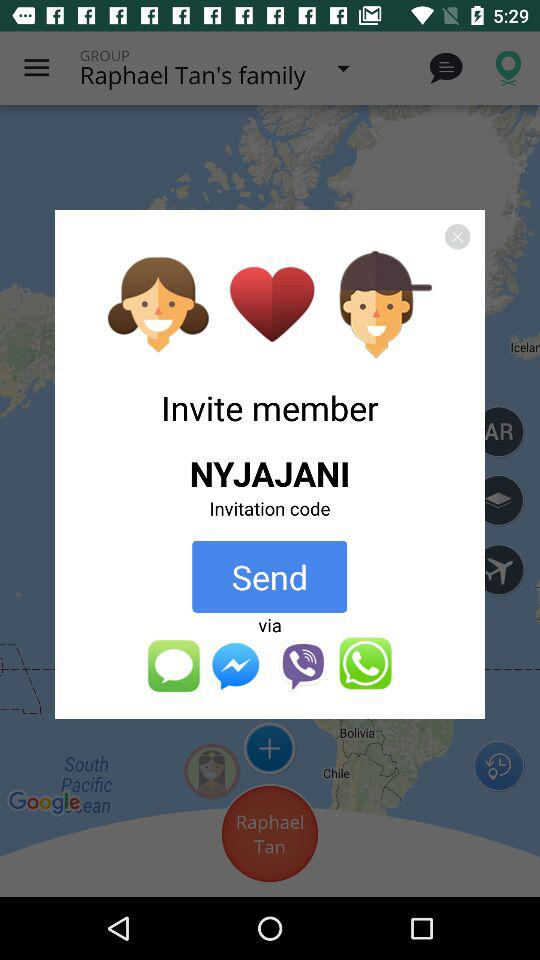Through which application can we share the invitation code? You can share the invitation code through "iMessage", "Messenger", "Viber" and "Whatsapp". 